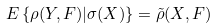Convert formula to latex. <formula><loc_0><loc_0><loc_500><loc_500>E \left \{ \rho ( Y , F ) | \sigma ( X ) \right \} = \tilde { \rho } ( X , F )</formula> 